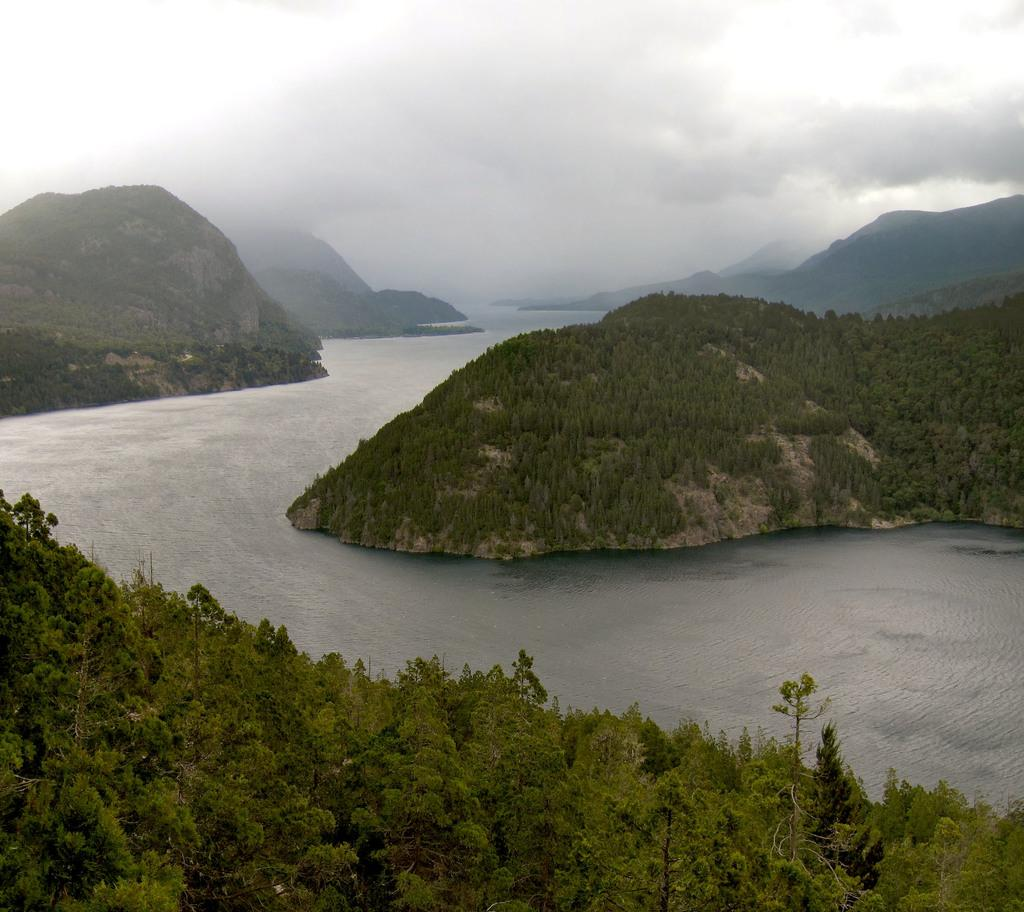What type of natural formation is visible in the image? There are mountains in the image. What can be seen on the mountains? There are trees on the mountains. What type of vegetation is present in the foreground of the image? There are trees in the foreground of the image. What is visible at the top of the image? There are clouds at the top of the image. What is visible at the bottom of the image? There is water at the bottom of the image. Where are the dolls playing on the railway in the image? There are no dolls or railway present in the image; it features mountains, trees, clouds, and water. 